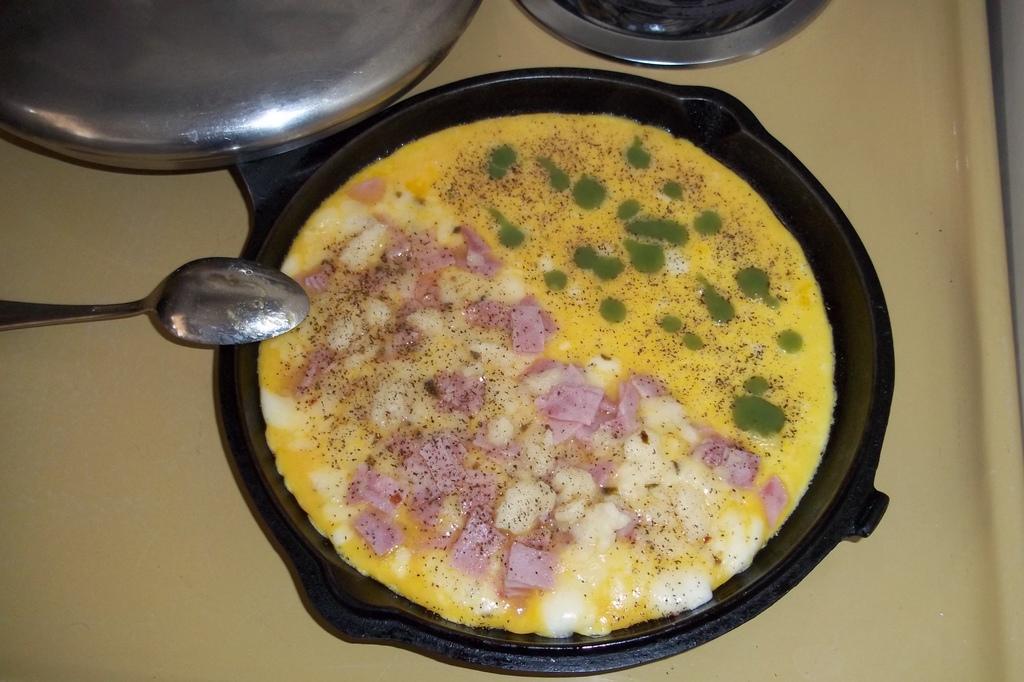Could you give a brief overview of what you see in this image? In this image I can see the pan with food. To the side I can see the few more utensils and the spoon. These are on the yellow color surface. 